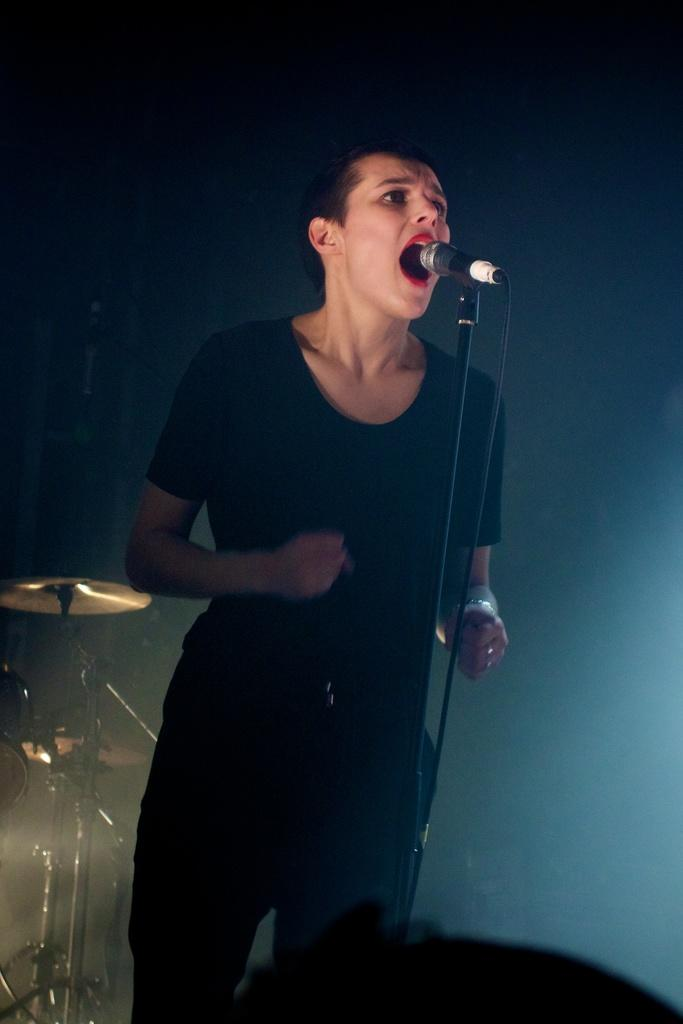Who is the main subject in the picture? There is a woman in the picture. What is the woman doing in the image? The woman is standing and singing. What is the woman using to amplify her voice? The woman is using a microphone. What musical instrument can be seen on the left side of the picture? There are drums on the left side of the picture. How would you describe the lighting in the image? The background of the image is dark. How many cats are visible in the image? There are no cats present in the image. What type of engine is being used by the woman in the image? The woman is not using an engine in the image; she is singing with a microphone. 